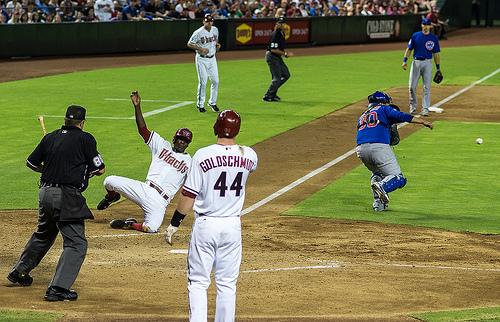List the two primary colors of the umpire's outfit. The umpire's outfit is black and gray. Describe the scene involving the baseball player and the umpire near the home plate. The umpire is watching the baseball player in a white uniform slide into the home plate. What is the number on the baseball jersey? The number on the baseball jersey is 44. What's happening with the baseball in the image? The baseball is flying in the air. Mention the color of the catcher's mask and the knee guards. The catcher's mask is blue, and the shin and knee guards are also blue. State the positions of the baseball players engaged in a game. The baseball players are engaged in various positions such as sliding into home plate, standing near third base, and trying to catch a ball. What is the occupation of the person wearing a black cap? The person wearing the black cap is an umpire. Identify the primary action happening in the baseball game. A baseball player in a white uniform is sliding into the home plate. Point out the player near third base and describe their uniform. The third baseman is wearing a blue and grey uniform. Explain what the spectators are doing in the image. The spectators are watching a baseball game. 